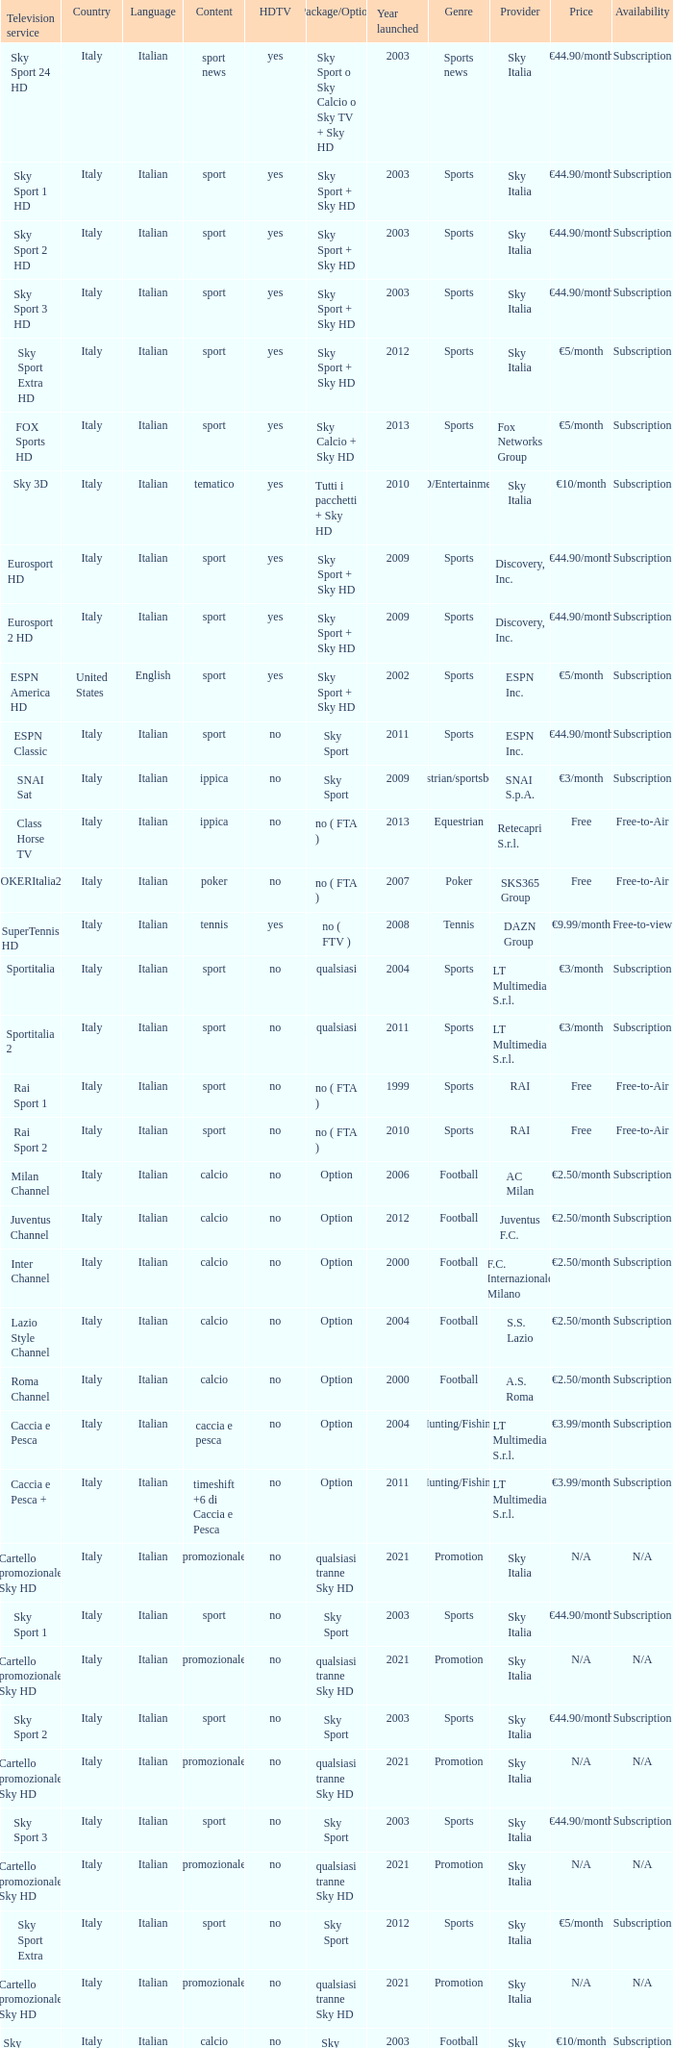What is Package/Option, when Content is Poker? No ( fta ). 